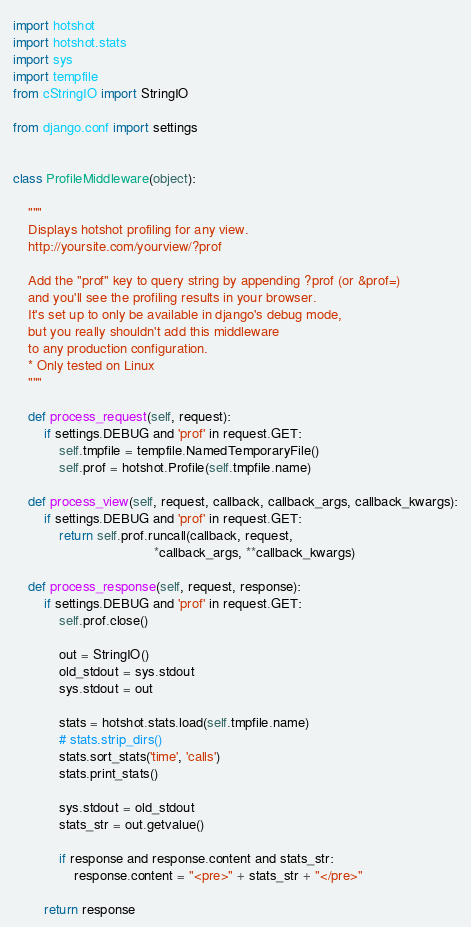<code> <loc_0><loc_0><loc_500><loc_500><_Python_>import hotshot
import hotshot.stats
import sys
import tempfile
from cStringIO import StringIO

from django.conf import settings


class ProfileMiddleware(object):

    """
    Displays hotshot profiling for any view.
    http://yoursite.com/yourview/?prof

    Add the "prof" key to query string by appending ?prof (or &prof=)
    and you'll see the profiling results in your browser.
    It's set up to only be available in django's debug mode,
    but you really shouldn't add this middleware
    to any production configuration.
    * Only tested on Linux
    """

    def process_request(self, request):
        if settings.DEBUG and 'prof' in request.GET:
            self.tmpfile = tempfile.NamedTemporaryFile()
            self.prof = hotshot.Profile(self.tmpfile.name)

    def process_view(self, request, callback, callback_args, callback_kwargs):
        if settings.DEBUG and 'prof' in request.GET:
            return self.prof.runcall(callback, request,
                                     *callback_args, **callback_kwargs)

    def process_response(self, request, response):
        if settings.DEBUG and 'prof' in request.GET:
            self.prof.close()

            out = StringIO()
            old_stdout = sys.stdout
            sys.stdout = out

            stats = hotshot.stats.load(self.tmpfile.name)
            # stats.strip_dirs()
            stats.sort_stats('time', 'calls')
            stats.print_stats()

            sys.stdout = old_stdout
            stats_str = out.getvalue()

            if response and response.content and stats_str:
                response.content = "<pre>" + stats_str + "</pre>"

        return response
</code> 